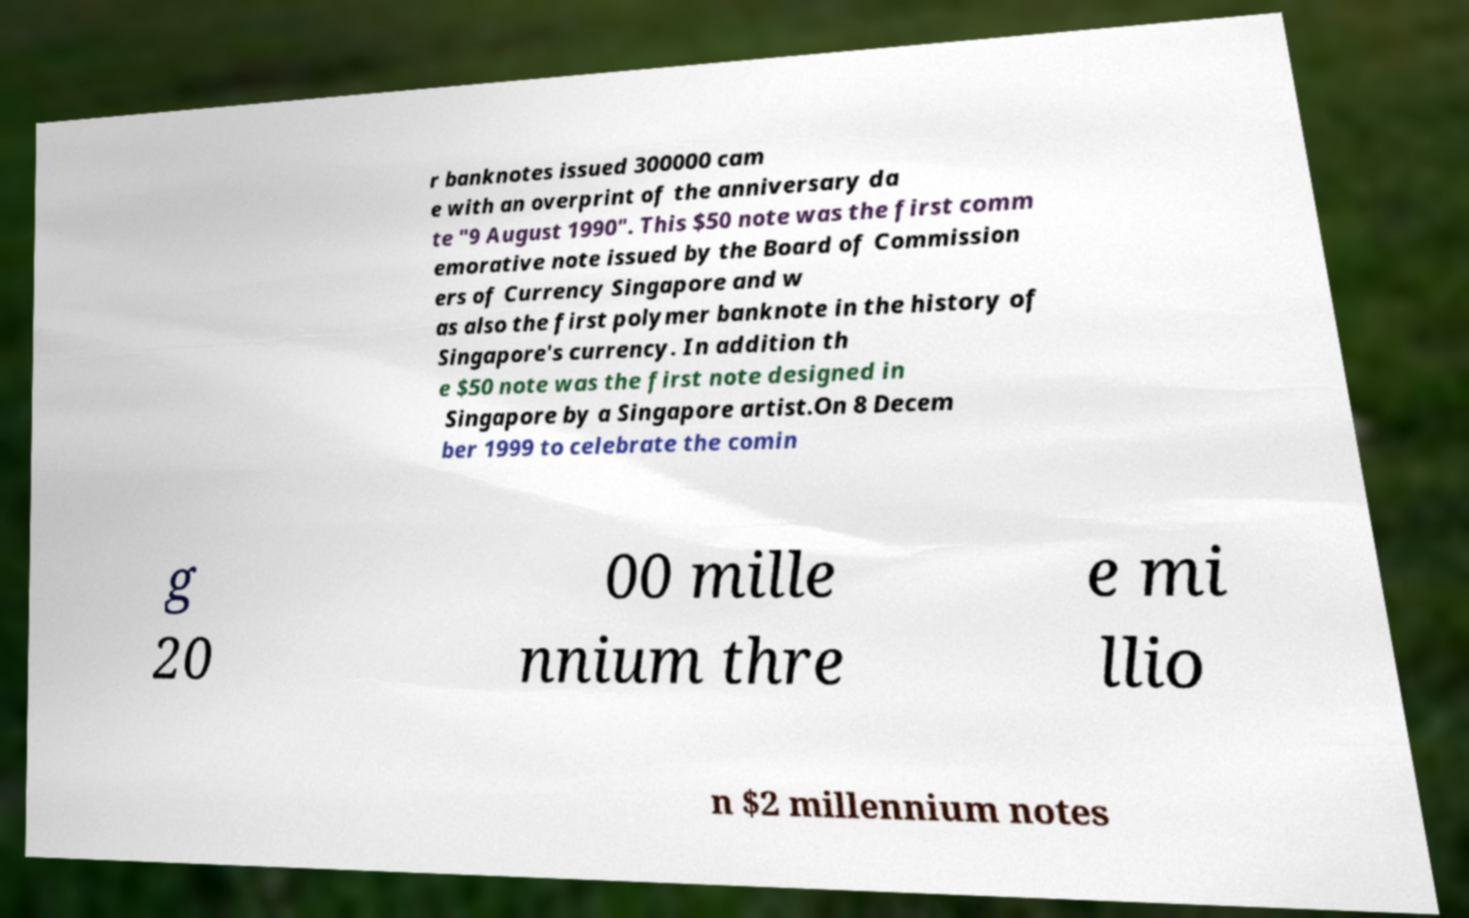There's text embedded in this image that I need extracted. Can you transcribe it verbatim? r banknotes issued 300000 cam e with an overprint of the anniversary da te "9 August 1990". This $50 note was the first comm emorative note issued by the Board of Commission ers of Currency Singapore and w as also the first polymer banknote in the history of Singapore's currency. In addition th e $50 note was the first note designed in Singapore by a Singapore artist.On 8 Decem ber 1999 to celebrate the comin g 20 00 mille nnium thre e mi llio n $2 millennium notes 